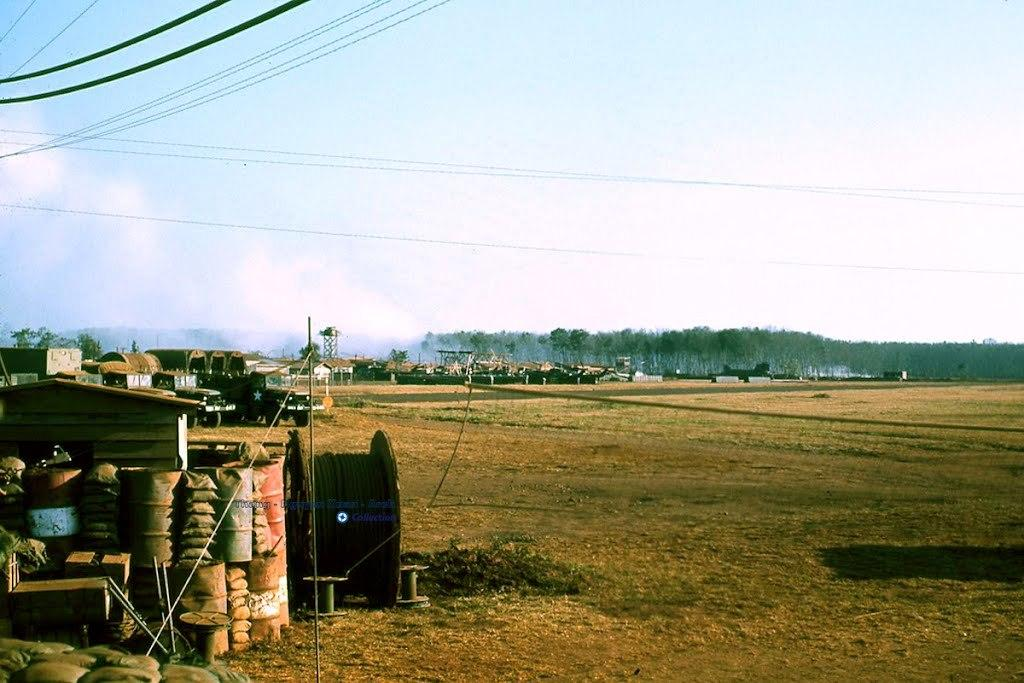What is the new object in the image? The new object in the image is not specified, but we can describe other elements in the image. What can be seen near the wheel in the image? There are oil barrels, vehicles, houses, trees, and the sky visible behind the wheel. What is in front of the wheel in the image? There are cables in front of the wheel. What type of beef is being served at the secretary's desk in the image? There is no beef or secretary present in the image. 